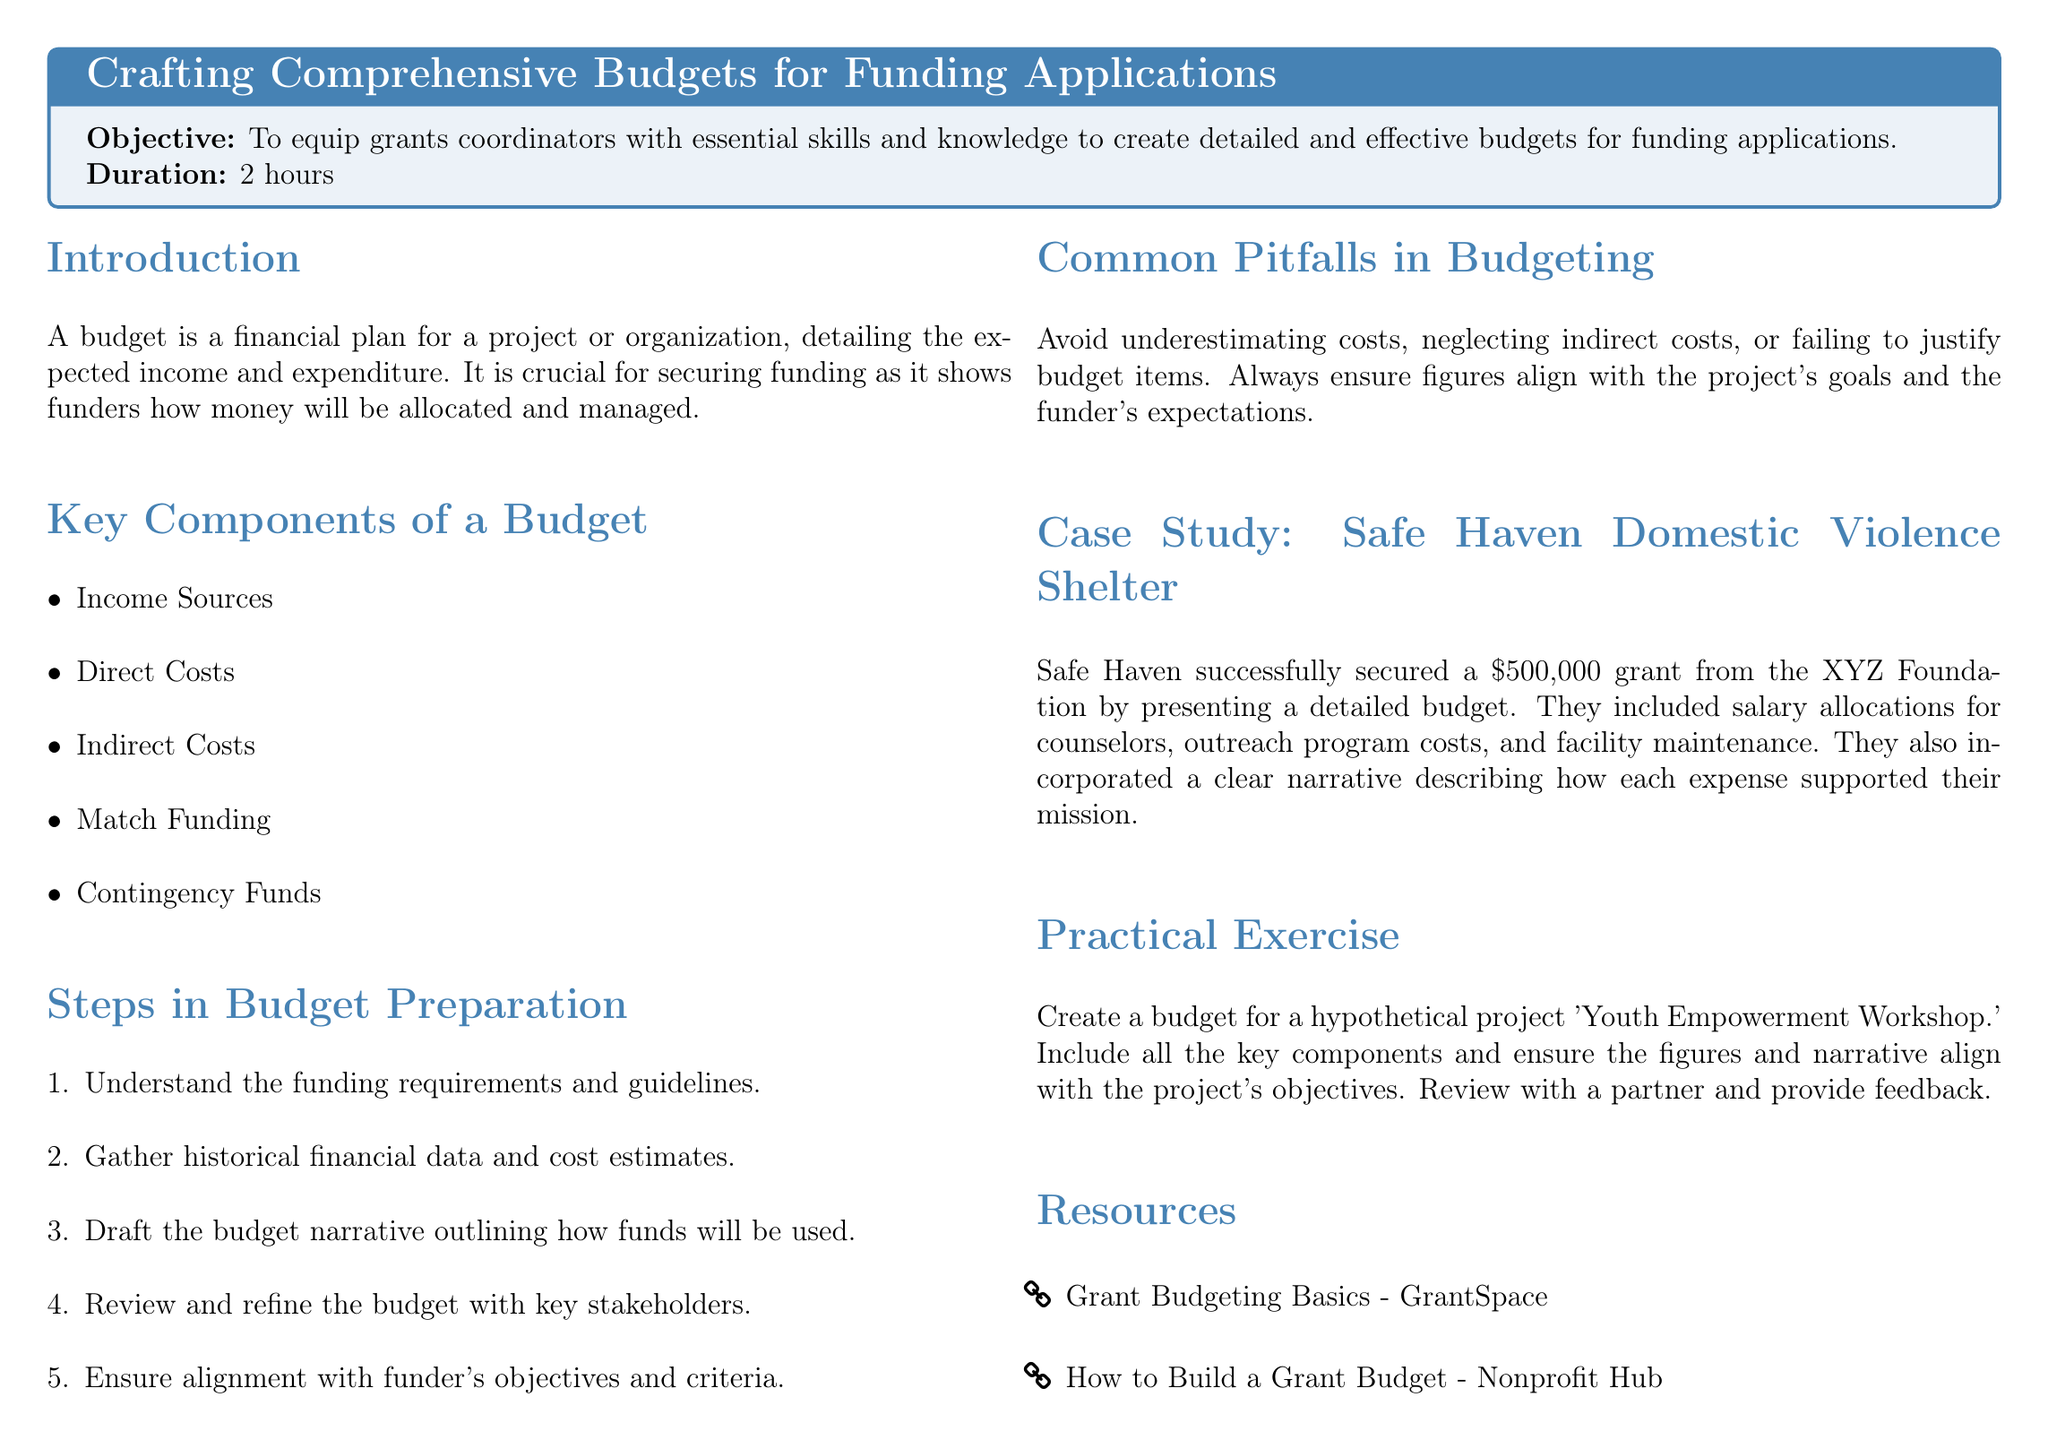What is the duration of the lesson? The duration of the lesson, as stated in the document, is how long the lesson will take to complete.
Answer: 2 hours What is the main objective of the lesson? The main objective is to equip grants coordinators with essential skills and knowledge necessary for creating budgets.
Answer: To equip grants coordinators with essential skills and knowledge to create detailed and effective budgets for funding applications What are the key components of a budget? The key components list several elements that are crucial for creating a budget.
Answer: Income Sources, Direct Costs, Indirect Costs, Match Funding, Contingency Funds What is one common pitfall in budgeting? This question asks for a specific mistake that can occur during budget preparation.
Answer: Underestimating costs How much grant money did Safe Haven secure? The document specifies the amount that the Safe Haven Domestic Violence Shelter received as a grant.
Answer: $500,000 Which organization provided the grant to Safe Haven? The question looks for the name of the funding organization mentioned in the case study.
Answer: XYZ Foundation What is the purpose of match funding? This asks for the definition or explanation of match funding as mentioned in the document.
Answer: To demonstrate financial commitment of the applicant Name one resource listed for further reading. This question seeks a specific example of supportive materials provided to the readers.
Answer: Grant Budgeting Basics - GrantSpace What is the final activity of the lesson? This question identifies the hands-on practice component included in the lesson plan.
Answer: Create a budget for a hypothetical project 'Youth Empowerment Workshop.' 